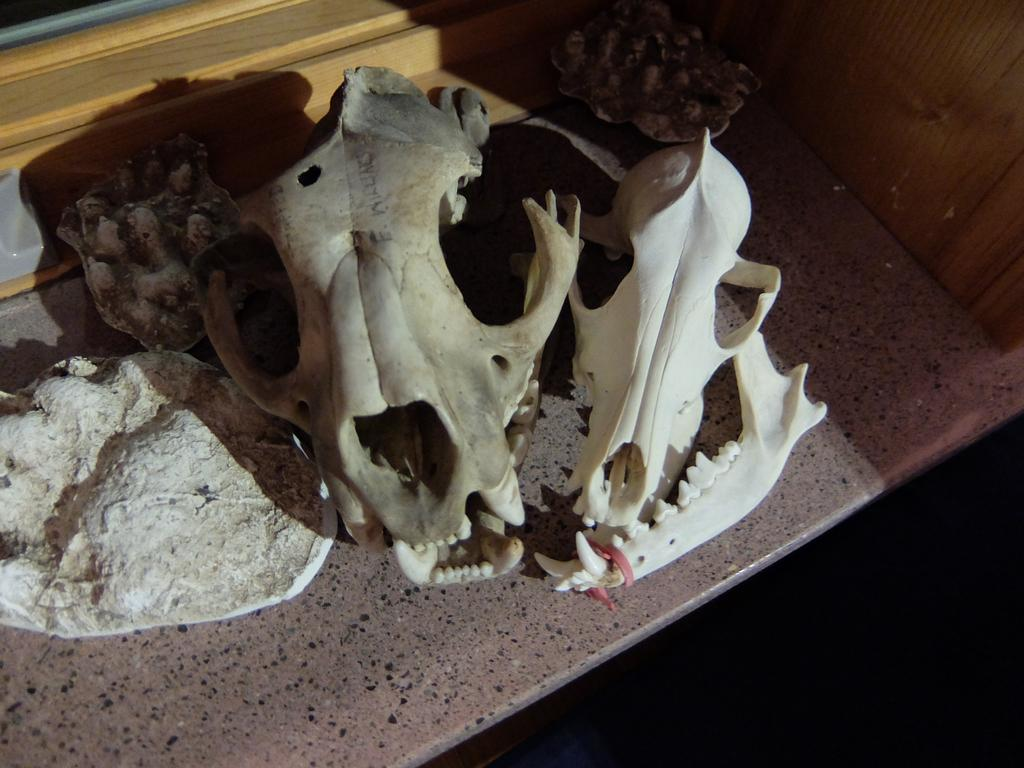What type of objects can be seen in the image? There are skulls and bones of animals in the image. What are these skulls and bones placed on? These skulls and bones are on an object. Where is the card located in the image? There is no card present in the image. What type of creature can be seen swimming in the lake in the image? There is no lake or creature swimming in it present in the image. 